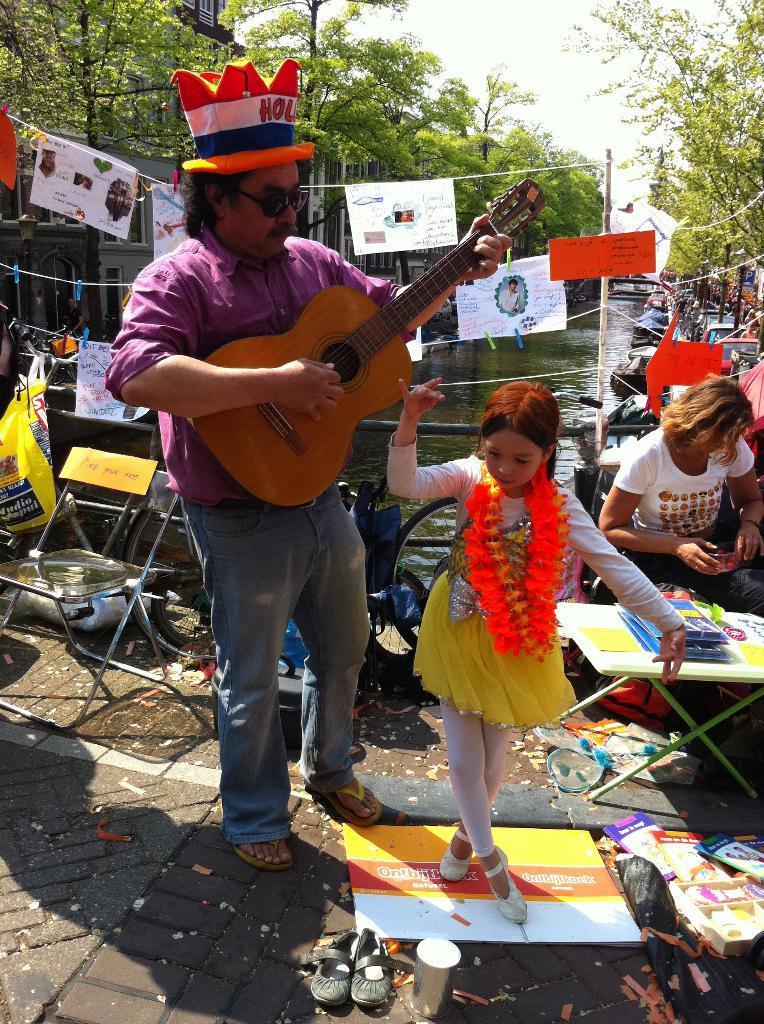How would you summarize this image in a sentence or two? In the picture we can find a man and a girl. The man is holding a guitar and standing, girl is standing in front of him. In the background we can find some trees, pole, chairs, and a person sitting near to it we can find a table and some books on it. 